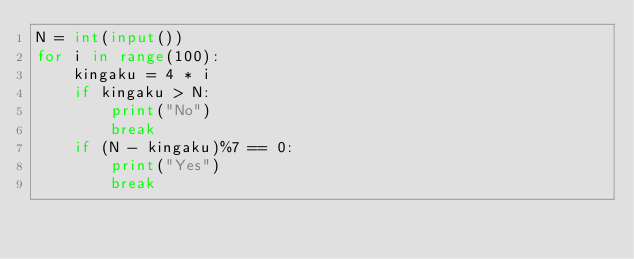Convert code to text. <code><loc_0><loc_0><loc_500><loc_500><_Python_>N = int(input())
for i in range(100):
    kingaku = 4 * i
    if kingaku > N:
        print("No")
        break
    if (N - kingaku)%7 == 0:
        print("Yes")
        break </code> 